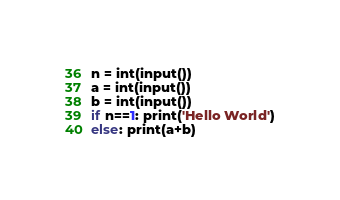<code> <loc_0><loc_0><loc_500><loc_500><_Python_>n = int(input())
a = int(input())
b = int(input())
if n==1: print('Hello World')
else: print(a+b)</code> 